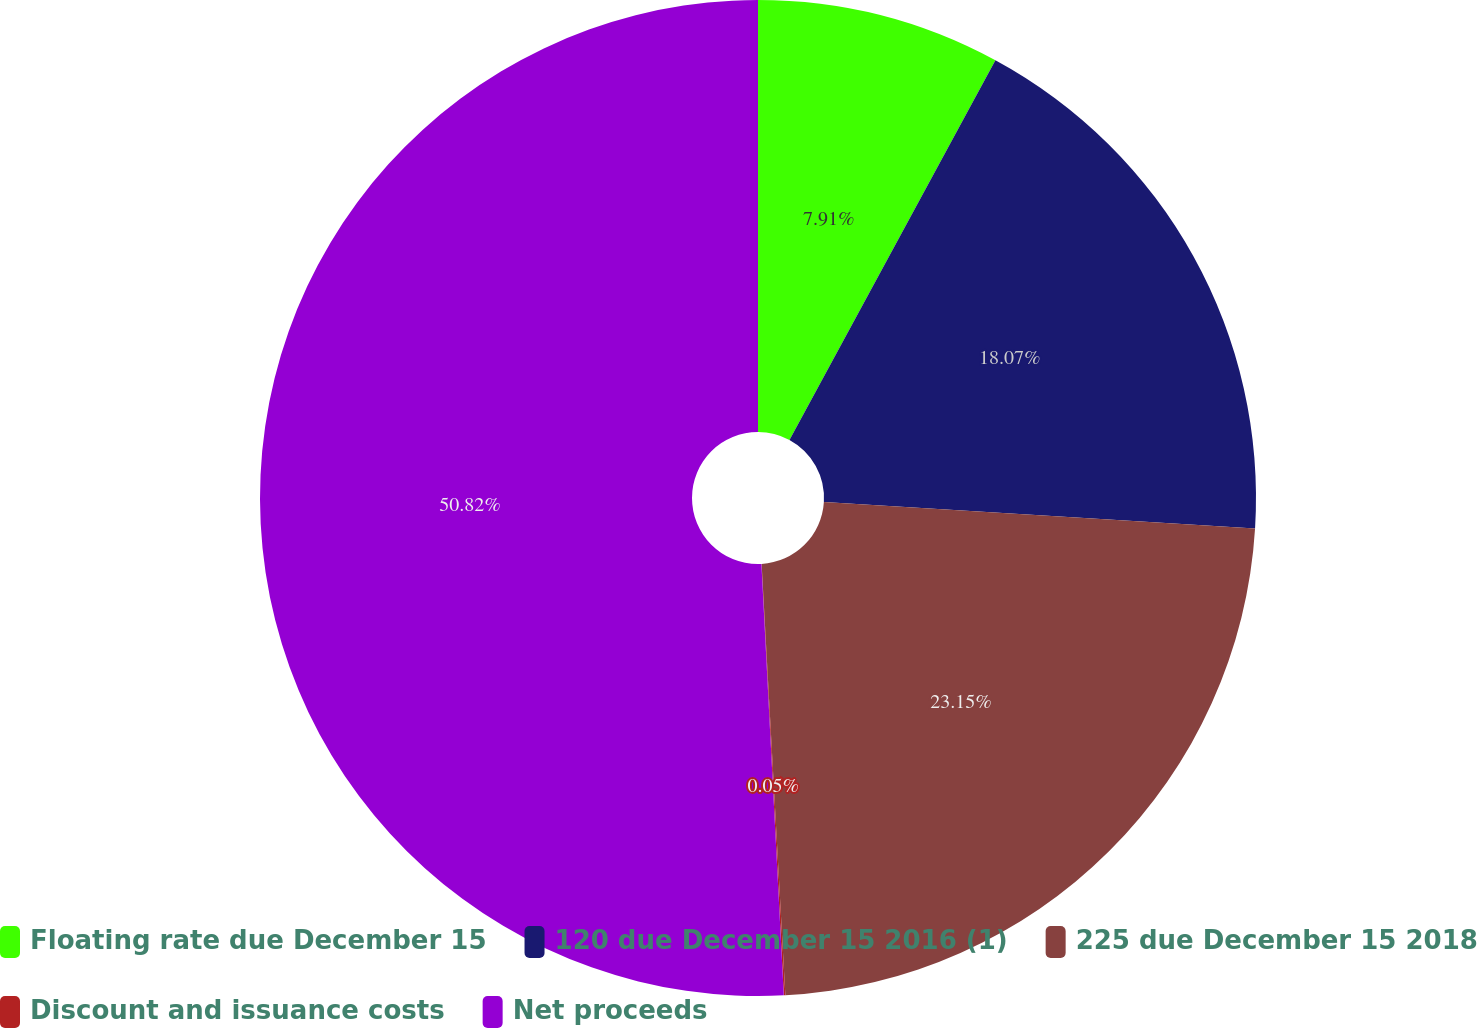<chart> <loc_0><loc_0><loc_500><loc_500><pie_chart><fcel>Floating rate due December 15<fcel>120 due December 15 2016 (1)<fcel>225 due December 15 2018<fcel>Discount and issuance costs<fcel>Net proceeds<nl><fcel>7.91%<fcel>18.07%<fcel>23.15%<fcel>0.05%<fcel>50.83%<nl></chart> 